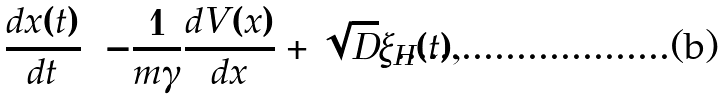<formula> <loc_0><loc_0><loc_500><loc_500>\frac { d x ( t ) } { d t } = - \frac { 1 } { m \gamma } \frac { d V ( x ) } { d x } + \sqrt { D } \xi _ { H } ( t ) ,</formula> 